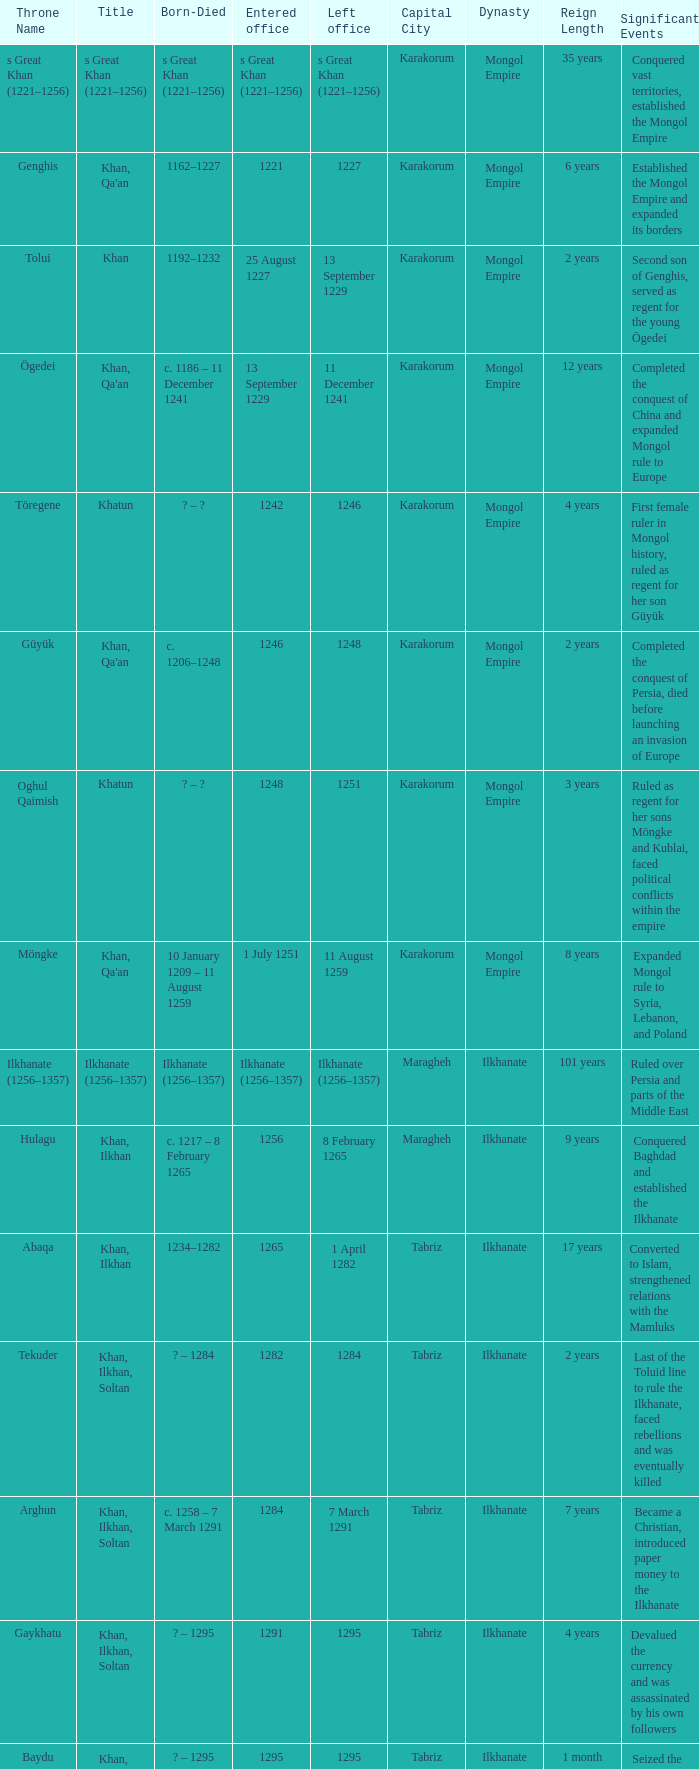What is the entered office that has 1337 as the left office? 12 April 1336. 